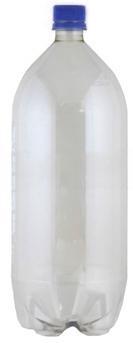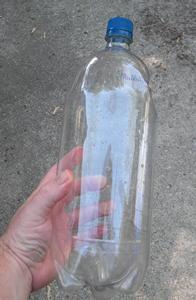The first image is the image on the left, the second image is the image on the right. Analyze the images presented: Is the assertion "One of the pictures shows at least two bottles standing upright side by side." valid? Answer yes or no. No. The first image is the image on the left, the second image is the image on the right. For the images displayed, is the sentence "At least two bottles have caps on them." factually correct? Answer yes or no. Yes. 